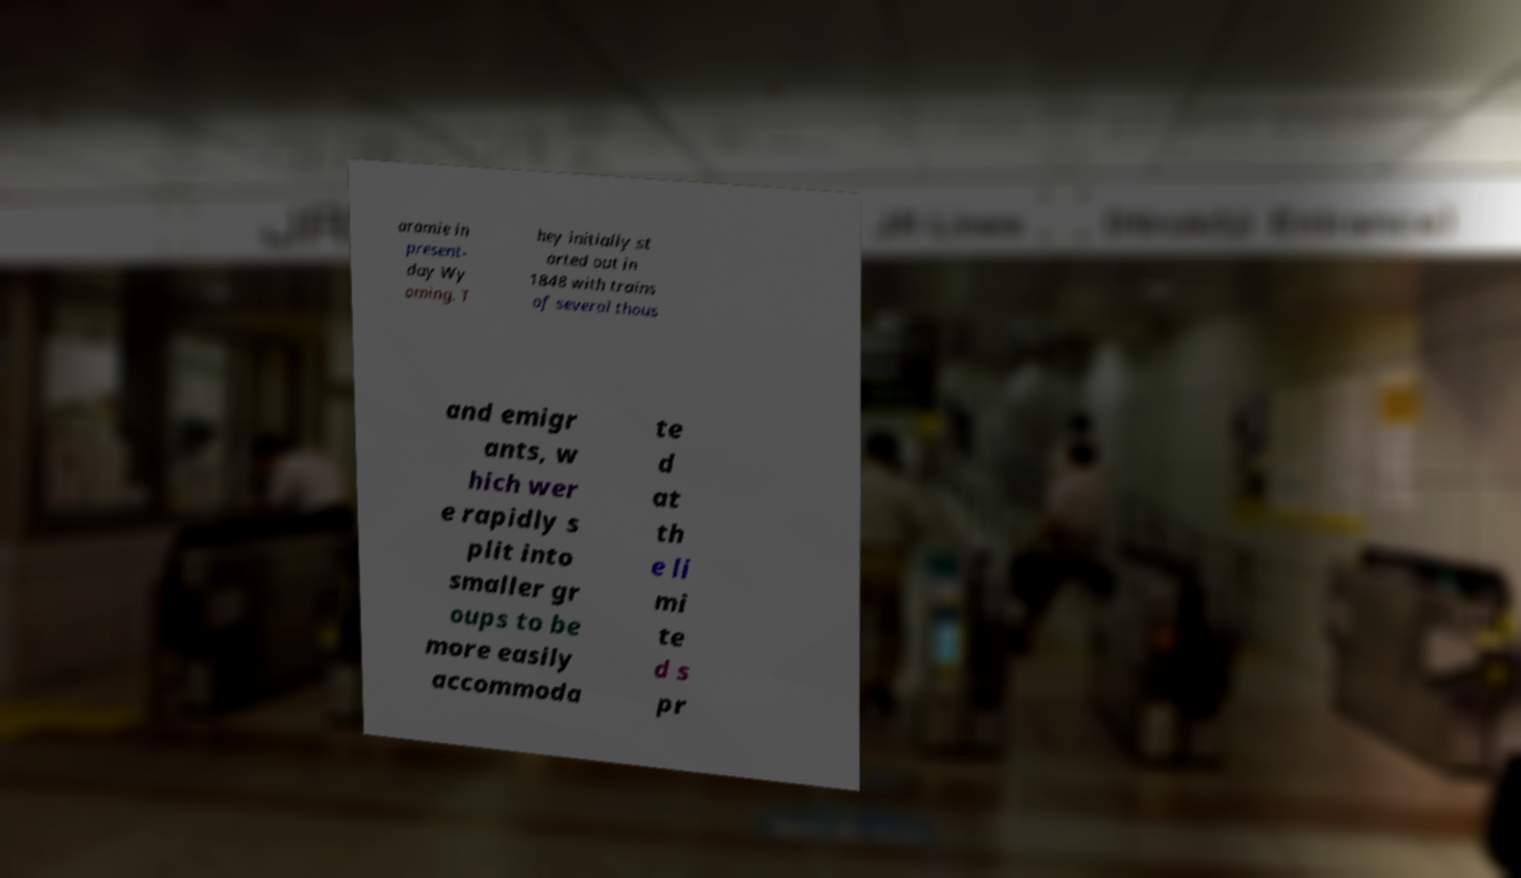What messages or text are displayed in this image? I need them in a readable, typed format. aramie in present- day Wy oming. T hey initially st arted out in 1848 with trains of several thous and emigr ants, w hich wer e rapidly s plit into smaller gr oups to be more easily accommoda te d at th e li mi te d s pr 